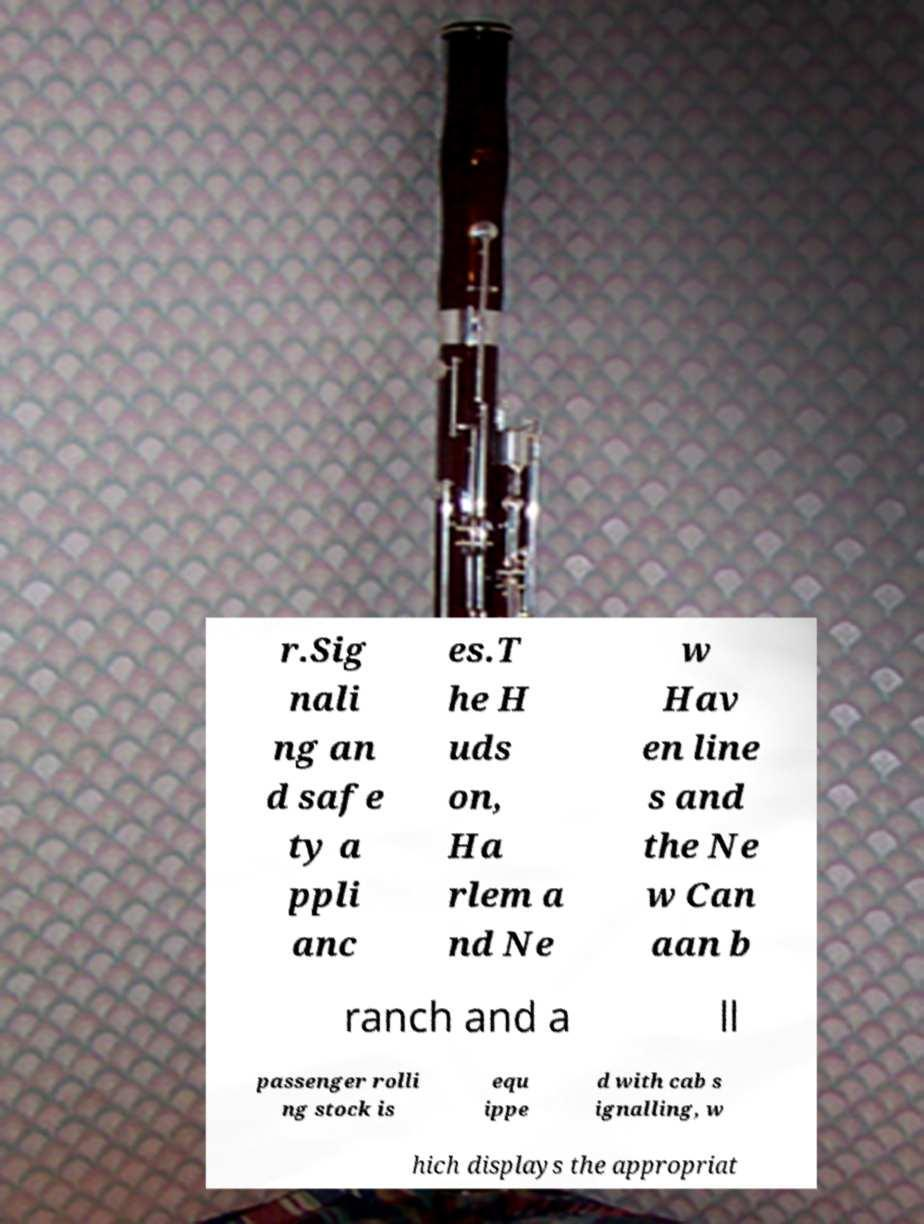There's text embedded in this image that I need extracted. Can you transcribe it verbatim? r.Sig nali ng an d safe ty a ppli anc es.T he H uds on, Ha rlem a nd Ne w Hav en line s and the Ne w Can aan b ranch and a ll passenger rolli ng stock is equ ippe d with cab s ignalling, w hich displays the appropriat 